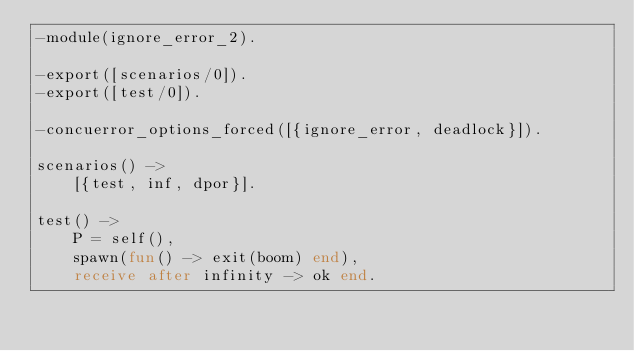<code> <loc_0><loc_0><loc_500><loc_500><_Erlang_>-module(ignore_error_2).

-export([scenarios/0]).
-export([test/0]).

-concuerror_options_forced([{ignore_error, deadlock}]).

scenarios() ->
    [{test, inf, dpor}].

test() ->
    P = self(),
    spawn(fun() -> exit(boom) end),
    receive after infinity -> ok end.
</code> 